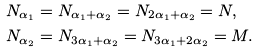Convert formula to latex. <formula><loc_0><loc_0><loc_500><loc_500>& N _ { \alpha _ { 1 } } = N _ { \alpha _ { 1 } + \alpha _ { 2 } } = N _ { 2 \alpha _ { 1 } + \alpha _ { 2 } } = N , \\ & N _ { \alpha _ { 2 } } = N _ { 3 \alpha _ { 1 } + \alpha _ { 2 } } = N _ { 3 \alpha _ { 1 } + 2 \alpha _ { 2 } } = M .</formula> 